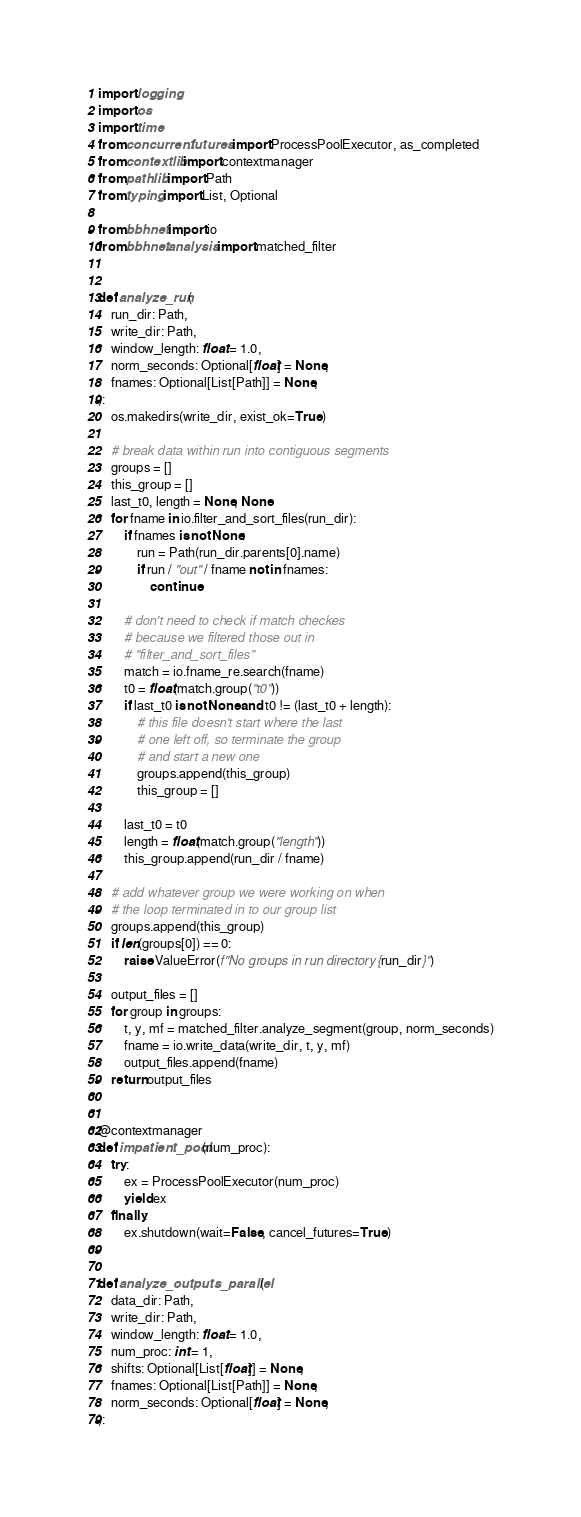<code> <loc_0><loc_0><loc_500><loc_500><_Python_>import logging
import os
import time
from concurrent.futures import ProcessPoolExecutor, as_completed
from contextlib import contextmanager
from pathlib import Path
from typing import List, Optional

from bbhnet import io
from bbhnet.analysis import matched_filter


def analyze_run(
    run_dir: Path,
    write_dir: Path,
    window_length: float = 1.0,
    norm_seconds: Optional[float] = None,
    fnames: Optional[List[Path]] = None,
):
    os.makedirs(write_dir, exist_ok=True)

    # break data within run into contiguous segments
    groups = []
    this_group = []
    last_t0, length = None, None
    for fname in io.filter_and_sort_files(run_dir):
        if fnames is not None:
            run = Path(run_dir.parents[0].name)
            if run / "out" / fname not in fnames:
                continue

        # don't need to check if match checkes
        # because we filtered those out in
        # "filter_and_sort_files"
        match = io.fname_re.search(fname)
        t0 = float(match.group("t0"))
        if last_t0 is not None and t0 != (last_t0 + length):
            # this file doesn't start where the last
            # one left off, so terminate the group
            # and start a new one
            groups.append(this_group)
            this_group = []

        last_t0 = t0
        length = float(match.group("length"))
        this_group.append(run_dir / fname)

    # add whatever group we were working on when
    # the loop terminated in to our group list
    groups.append(this_group)
    if len(groups[0]) == 0:
        raise ValueError(f"No groups in run directory {run_dir}")

    output_files = []
    for group in groups:
        t, y, mf = matched_filter.analyze_segment(group, norm_seconds)
        fname = io.write_data(write_dir, t, y, mf)
        output_files.append(fname)
    return output_files


@contextmanager
def impatient_pool(num_proc):
    try:
        ex = ProcessPoolExecutor(num_proc)
        yield ex
    finally:
        ex.shutdown(wait=False, cancel_futures=True)


def analyze_outputs_parallel(
    data_dir: Path,
    write_dir: Path,
    window_length: float = 1.0,
    num_proc: int = 1,
    shifts: Optional[List[float]] = None,
    fnames: Optional[List[Path]] = None,
    norm_seconds: Optional[float] = None,
):</code> 